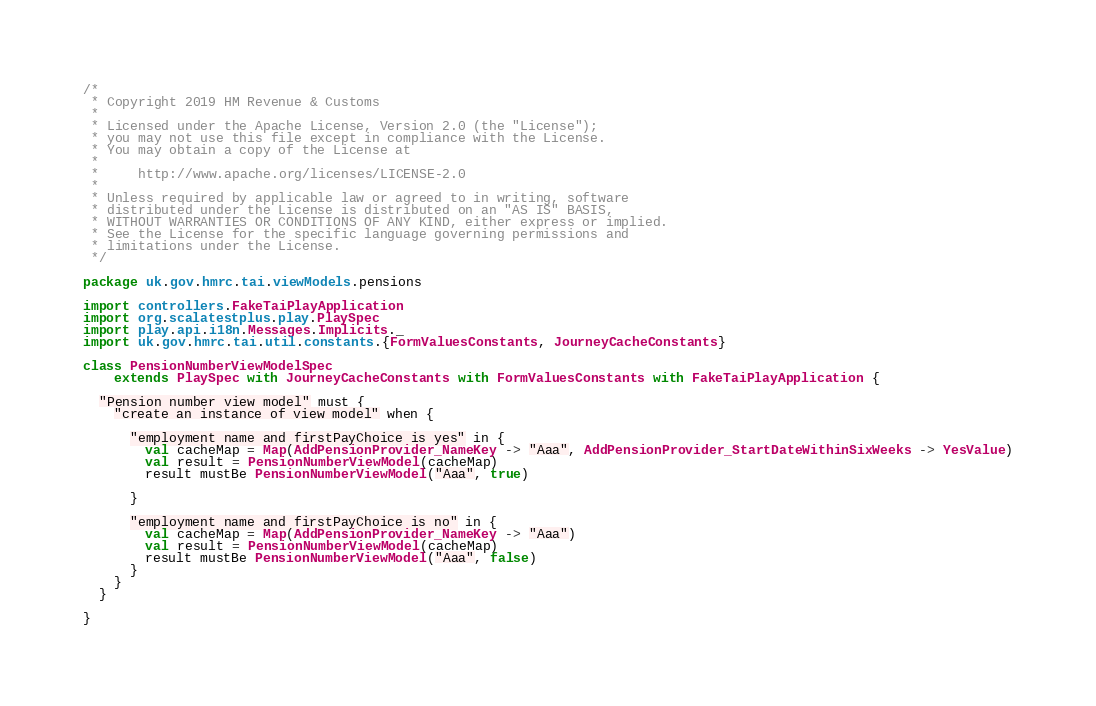Convert code to text. <code><loc_0><loc_0><loc_500><loc_500><_Scala_>/*
 * Copyright 2019 HM Revenue & Customs
 *
 * Licensed under the Apache License, Version 2.0 (the "License");
 * you may not use this file except in compliance with the License.
 * You may obtain a copy of the License at
 *
 *     http://www.apache.org/licenses/LICENSE-2.0
 *
 * Unless required by applicable law or agreed to in writing, software
 * distributed under the License is distributed on an "AS IS" BASIS,
 * WITHOUT WARRANTIES OR CONDITIONS OF ANY KIND, either express or implied.
 * See the License for the specific language governing permissions and
 * limitations under the License.
 */

package uk.gov.hmrc.tai.viewModels.pensions

import controllers.FakeTaiPlayApplication
import org.scalatestplus.play.PlaySpec
import play.api.i18n.Messages.Implicits._
import uk.gov.hmrc.tai.util.constants.{FormValuesConstants, JourneyCacheConstants}

class PensionNumberViewModelSpec
    extends PlaySpec with JourneyCacheConstants with FormValuesConstants with FakeTaiPlayApplication {

  "Pension number view model" must {
    "create an instance of view model" when {

      "employment name and firstPayChoice is yes" in {
        val cacheMap = Map(AddPensionProvider_NameKey -> "Aaa", AddPensionProvider_StartDateWithinSixWeeks -> YesValue)
        val result = PensionNumberViewModel(cacheMap)
        result mustBe PensionNumberViewModel("Aaa", true)

      }

      "employment name and firstPayChoice is no" in {
        val cacheMap = Map(AddPensionProvider_NameKey -> "Aaa")
        val result = PensionNumberViewModel(cacheMap)
        result mustBe PensionNumberViewModel("Aaa", false)
      }
    }
  }

}
</code> 